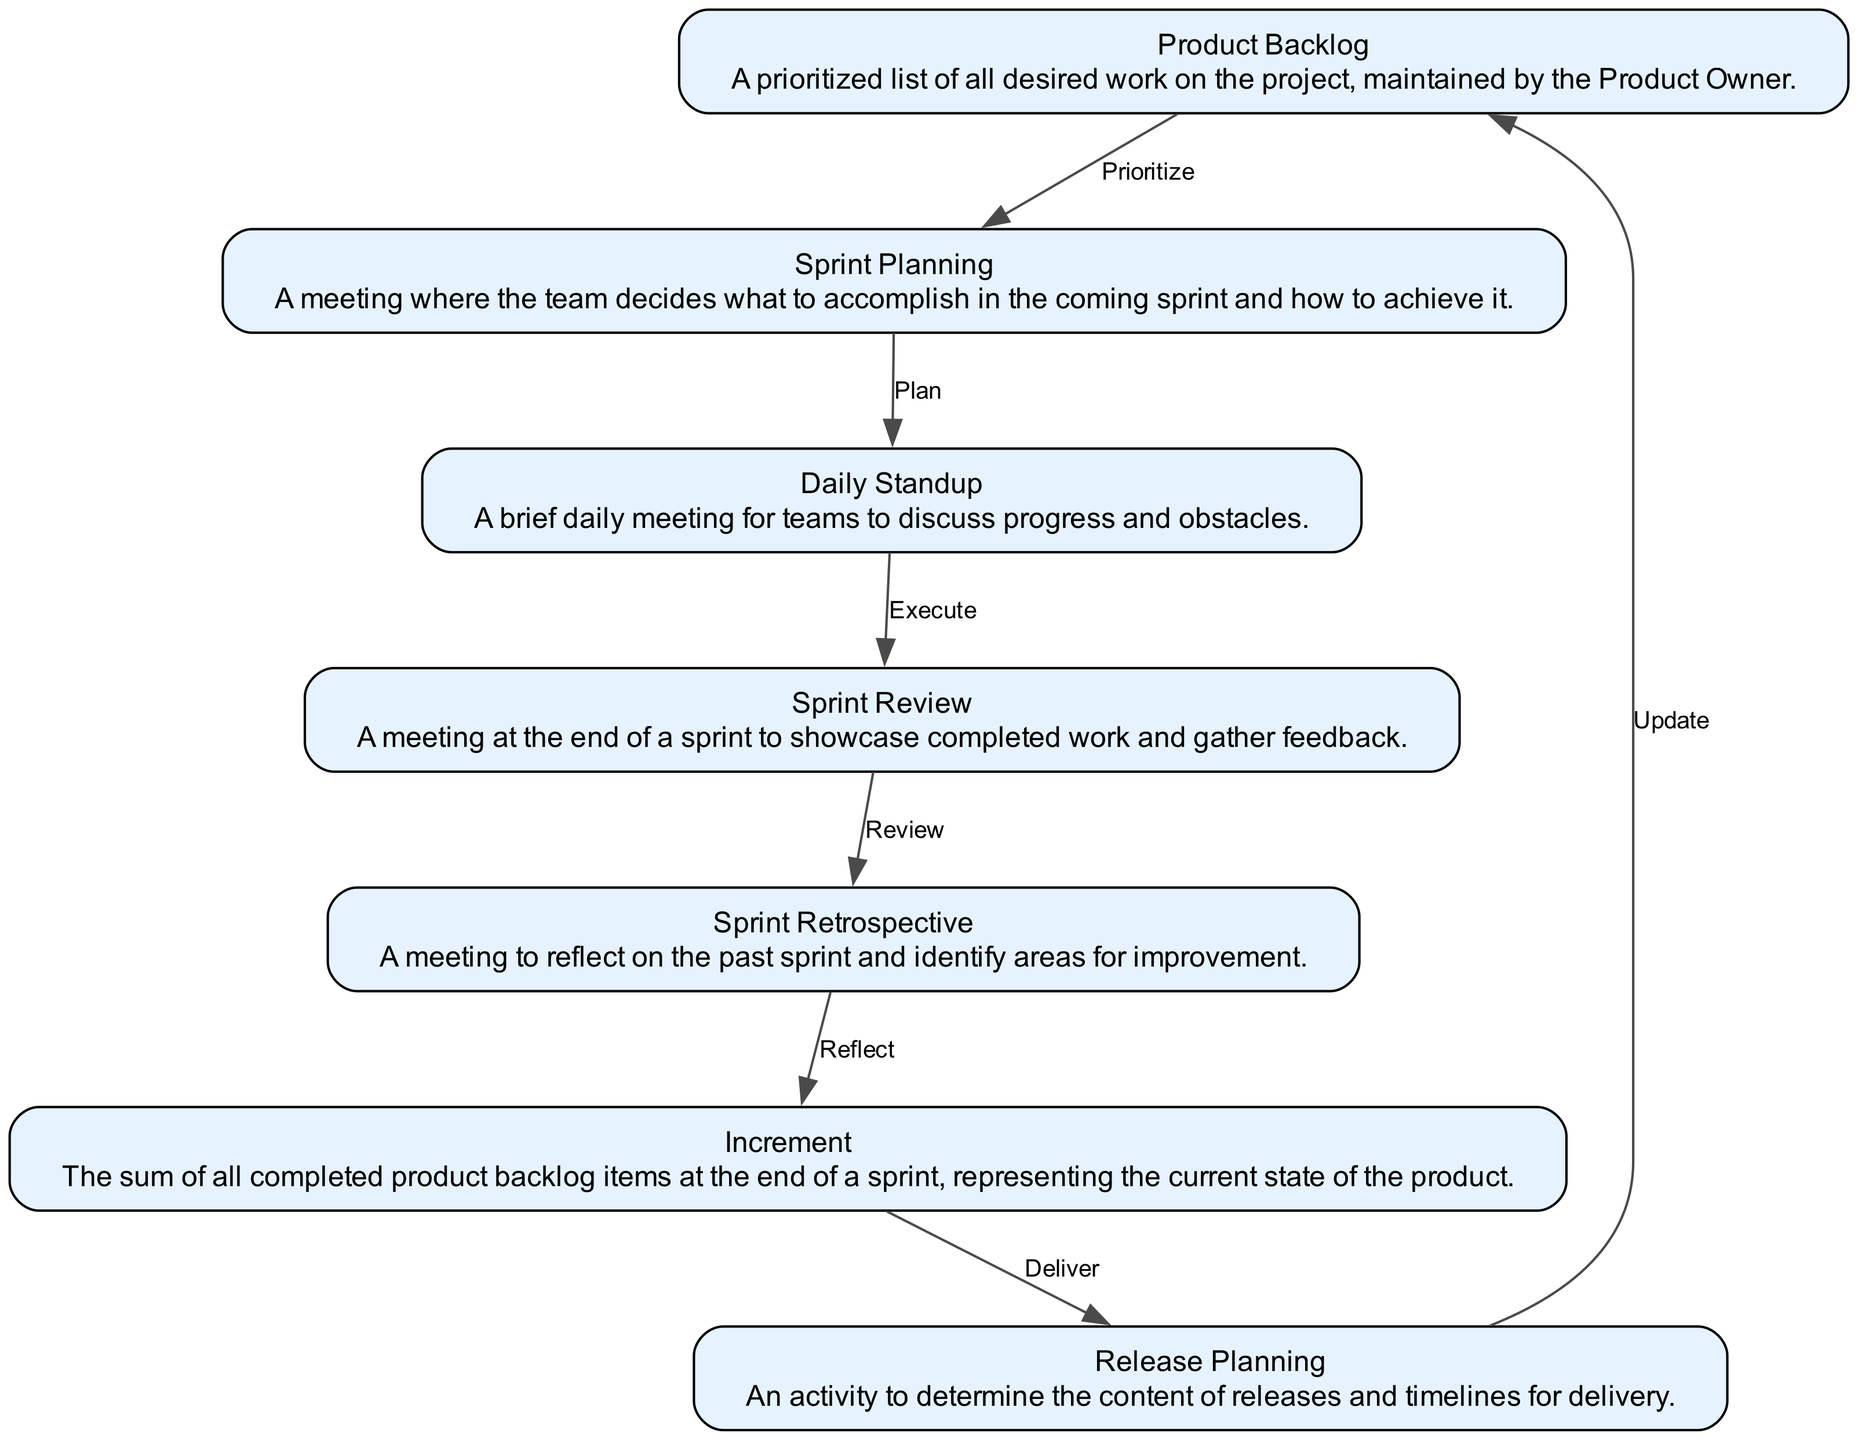What is the initial element in the flowchart? The initial element in the flowchart is the "Product Backlog". It is the starting point of the Agile workflow, indicating that the project begins with listing and prioritizing the work.
Answer: Product Backlog How many elements are in the diagram? The diagram contains a total of seven elements. Each element corresponds to a stage in the Agile software development lifecycle, reflecting different phases of the workflow.
Answer: Seven What is the relationship between the "Sprint Planning" and "Daily Standup"? The relationship is that "Sprint Planning" leads to "Daily Standup". After planning what to accomplish in the sprint, the team meets daily to discuss their progress, creating a flow from one to the other.
Answer: Plan What follows the "Sprint Review" in the workflow? Following the "Sprint Review", the next step in the workflow is the "Sprint Retrospective". This indicates that after reviewing work completed during the sprint, the team reflects on their performance.
Answer: Sprint Retrospective What is the final output of the workflow? The final output of the workflow is the "Release Planning". This signifies that after the completion of the increment, the focus shifts to planning for the upcoming releases based on the updates made.
Answer: Release Planning What is the purpose of the "Sprint Retrospective" in the cycle? The purpose of the "Sprint Retrospective" is to identify areas for improvement. This meeting allows the team to reflect on the past sprint and suggest changes for better performance in future sprints.
Answer: Identify areas for improvement Which element is connected to "Increment" before "Release Planning"? The element connected to "Increment" before "Release Planning" is "Sprint Retrospective". This shows that after evaluating the increment, the team proceeds to the release planning stage.
Answer: Sprint Retrospective How many edges connect the elements in the diagram? There are a total of six edges connecting the elements in the diagram. Each edge signifies the flow and relationship between the stages of the Agile development process.
Answer: Six 